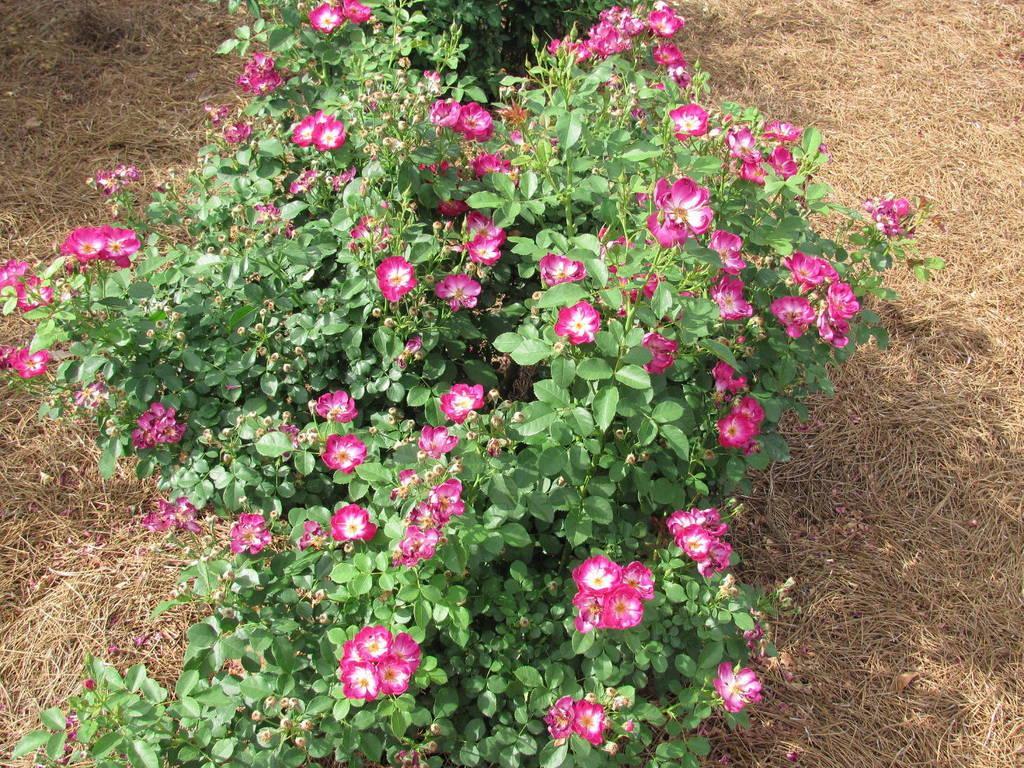Can you describe this image briefly? This image is consists of garden roses plants in the image and there is dried grass floor on the right and left side of the image. 